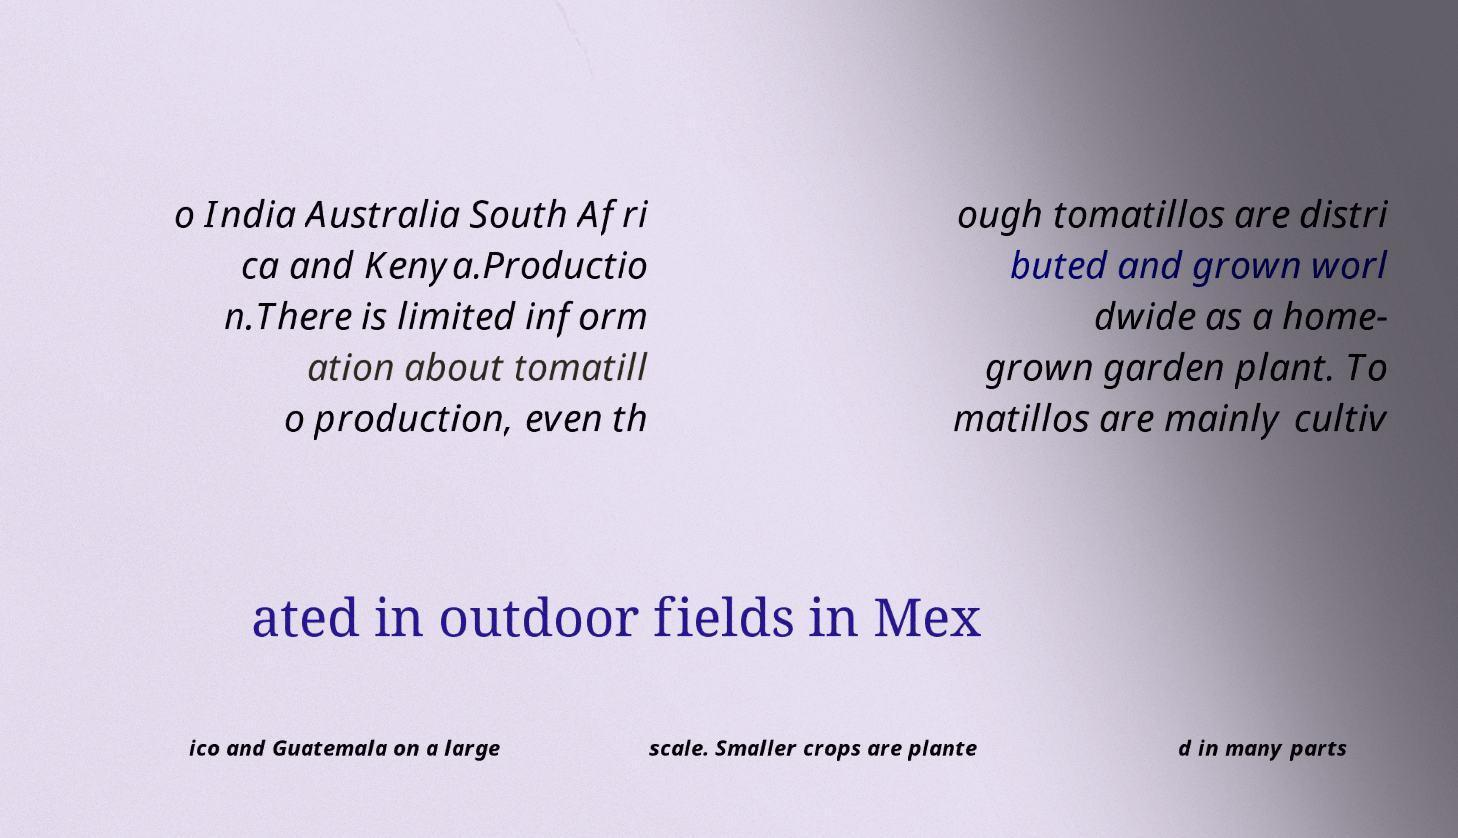Could you assist in decoding the text presented in this image and type it out clearly? o India Australia South Afri ca and Kenya.Productio n.There is limited inform ation about tomatill o production, even th ough tomatillos are distri buted and grown worl dwide as a home- grown garden plant. To matillos are mainly cultiv ated in outdoor fields in Mex ico and Guatemala on a large scale. Smaller crops are plante d in many parts 